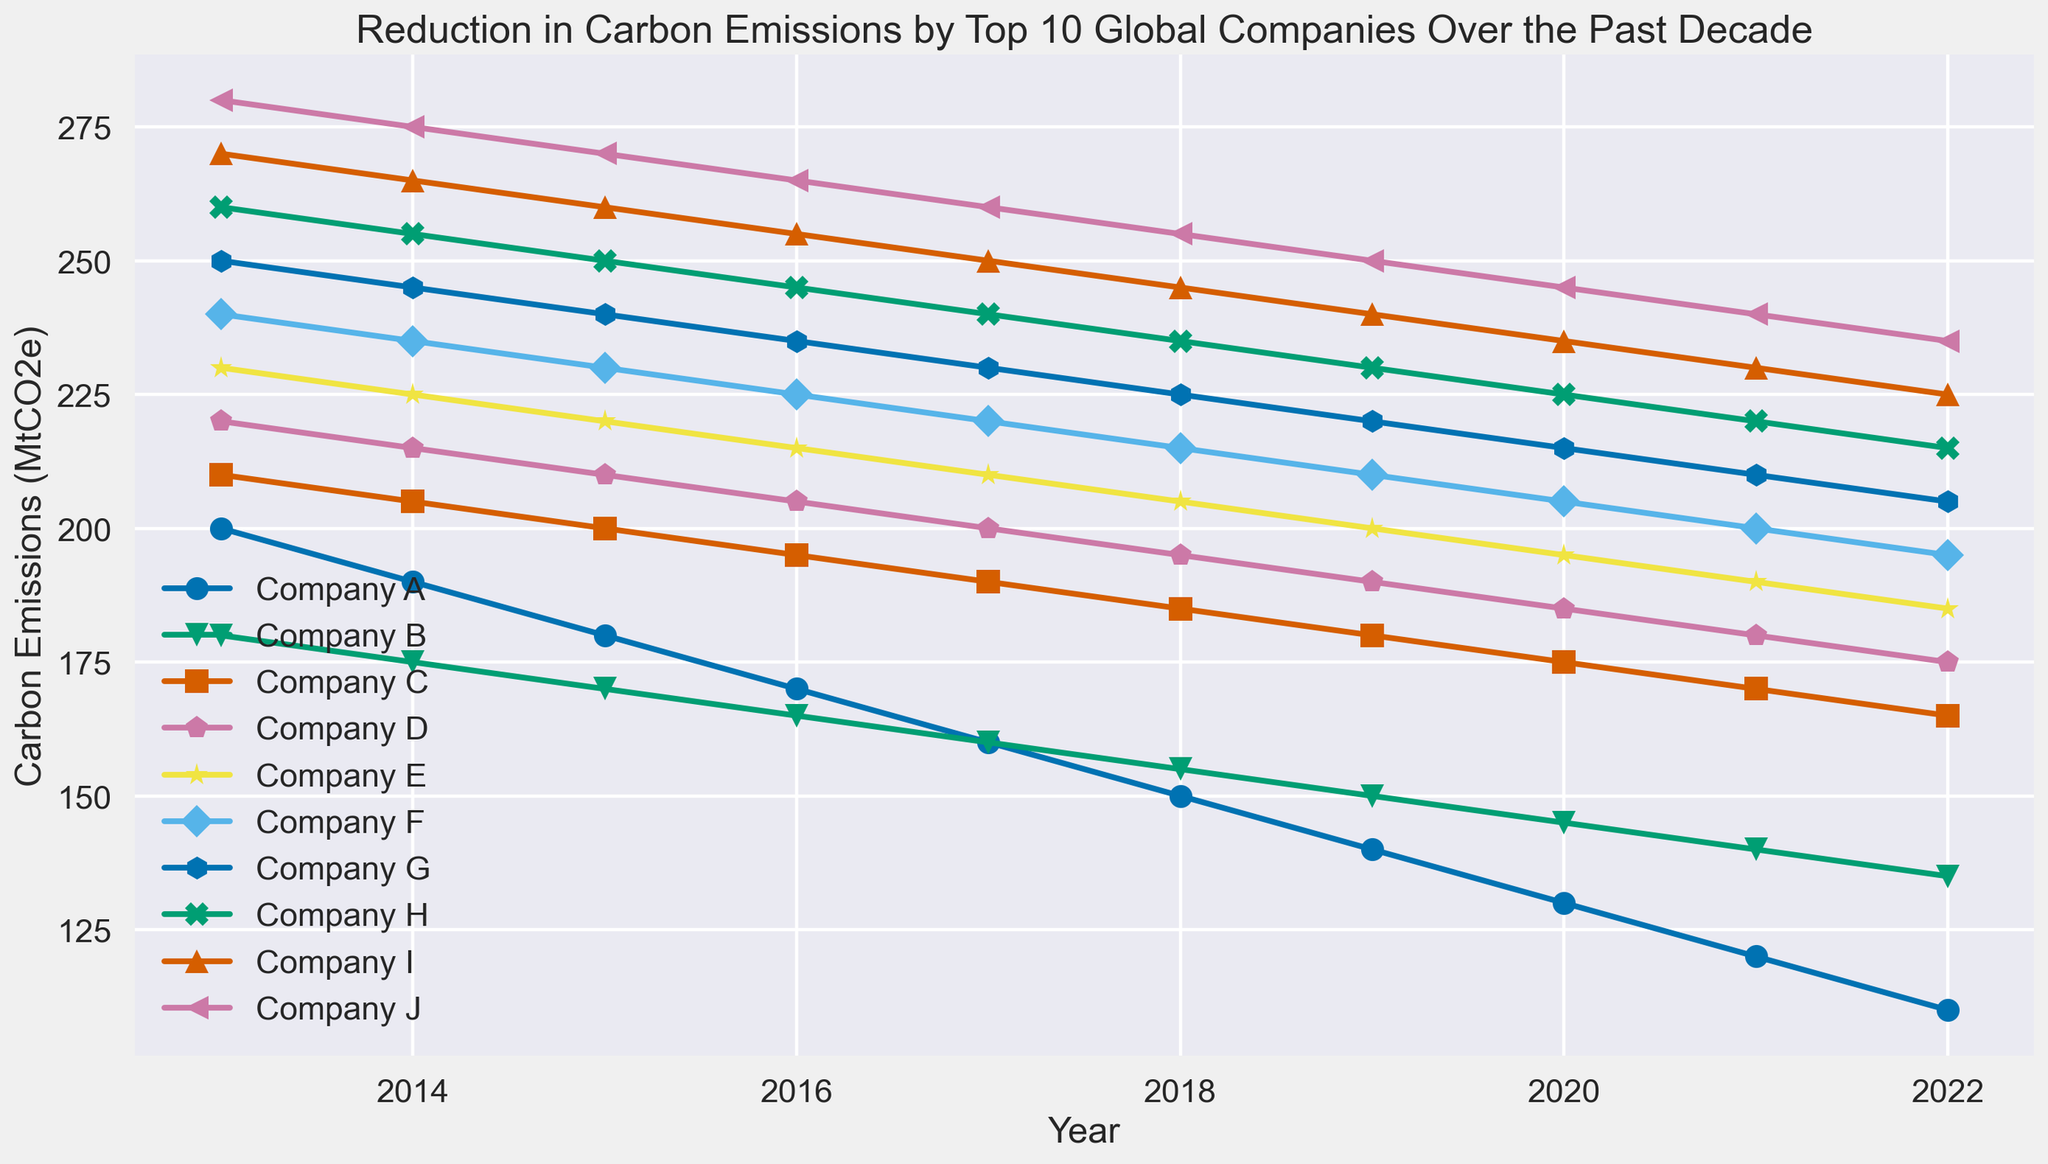What trend do you observe in carbon emissions for all companies over the past decade? Looking at the plot, all companies show a downward trend in their carbon emissions over the past decade. This means each company's line continuously descends from left to right.
Answer: Decreasing trend Which company has the steepest reduction in carbon emissions between 2013 and 2022? To find the steepest reduction, we measure the vertical distance between the 2013 and 2022 points for each company line. Company J decreases the most from 280 MtCO2e to 235 MtCO2e, a difference of 45 MtCO2e.
Answer: Company J How does the carbon emission reduction of Company A compare to Company B in 2022? In 2022, the carbon emissions for Company A are 110 MtCO2e and for Company B are 135 MtCO2e. Comparing the two, Company A has 25 MtCO2e less emissions than Company B.
Answer: Company A has lower emissions Between which consecutive years does Company H achieve its largest reduction? Calculating consecutive year differences for Company H, the largest single reduction is between 2013 (260 MtCO2e) and 2014 (255 MtCO2e), showing a 5 MtCO2e reduction.
Answer: 2013-2014 What is the average carbon emission for Company C over the decade? Summing the annual emissions from 2013 to 2022 for Company C (210 + 205 + 200 + 195 + 190 + 185 + 180 + 175 + 170 + 165) gives 1875. Divided by 10 years, the average is 187.5 MtCO2e.
Answer: 187.5 MtCO2e Which company had the lowest carbon emissions in 2020? Observing the 2020 data points on the plot, Company A has the lowest emissions with 130 MtCO2e.
Answer: Company A In 2017, how do the carbon emissions of Company F compare to Company G? In 2017, Company F’s emissions are at 220 MtCO2e while Company G’s emissions are 230 MtCO2e. Thus, Company F has 10 MtCO2e less emissions compared to Company G.
Answer: Company F has lower emissions Which company shows the most consistent reduction in carbon emissions over the decade? By examining the slope and the smoothness of each company's line, Company A shows a very consistent reduction, with uniform decrements each year.
Answer: Company A Which year saw the largest overall drop in carbon emissions across all companies? We need to compare the total sum of carbon emissions for each consecutive year. The largest drop can be analyzed visually and mathematically if required for every pair of consecutive years. The visible largest drop is typically found between 2019 and 2020.
Answer: 2019-2020 What is the total reduction in carbon emissions for Company I between 2013 and 2022? Subtract Company I's emissions in 2022 (225 MtCO2e) from its emissions in 2013 (270 MtCO2e): 270 - 225 = 45 MtCO2e.
Answer: 45 MtCO2e 